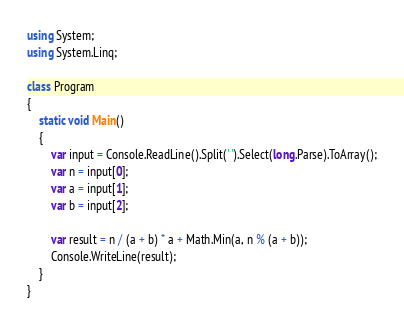Convert code to text. <code><loc_0><loc_0><loc_500><loc_500><_C#_>using System;
using System.Linq;

class Program
{
    static void Main()
    {
        var input = Console.ReadLine().Split(' ').Select(long.Parse).ToArray();
        var n = input[0];
        var a = input[1];
        var b = input[2];

        var result = n / (a + b) * a + Math.Min(a, n % (a + b));
        Console.WriteLine(result);
    }
}</code> 